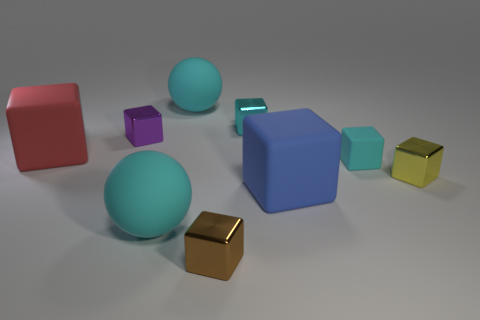What is the material of the other small object that is the same color as the tiny matte object?
Keep it short and to the point. Metal. Do the big cube that is behind the yellow block and the brown thing have the same material?
Provide a succinct answer. No. What material is the large block on the left side of the brown shiny block?
Your response must be concise. Rubber. There is a rubber sphere that is in front of the tiny cyan cube that is on the right side of the large blue thing; how big is it?
Your answer should be very brief. Large. Is there a small purple cube that has the same material as the tiny brown object?
Your response must be concise. Yes. What is the shape of the tiny thing that is behind the small thing that is to the left of the matte ball that is behind the tiny yellow thing?
Your response must be concise. Cube. Is the color of the matte sphere behind the tiny cyan metallic object the same as the large sphere that is in front of the cyan metallic object?
Your answer should be very brief. Yes. There is a purple shiny cube; are there any large red blocks on the left side of it?
Provide a short and direct response. Yes. What number of large yellow objects have the same shape as the big red thing?
Offer a very short reply. 0. What color is the metal object in front of the large rubber block to the right of the cyan sphere that is in front of the large blue matte object?
Offer a terse response. Brown. 